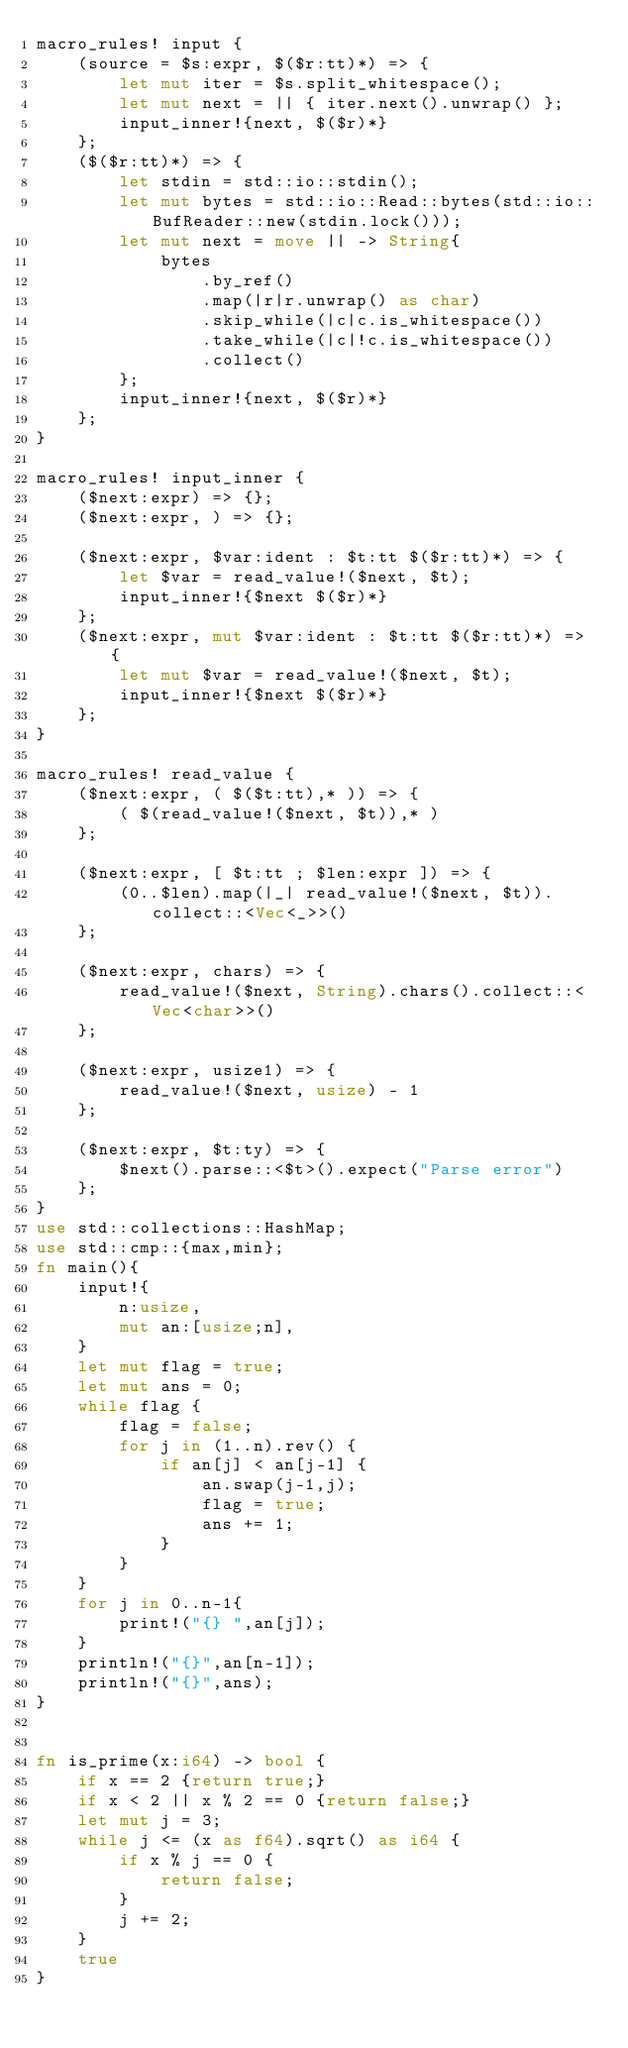<code> <loc_0><loc_0><loc_500><loc_500><_Rust_>macro_rules! input {
    (source = $s:expr, $($r:tt)*) => {
        let mut iter = $s.split_whitespace();
        let mut next = || { iter.next().unwrap() };
        input_inner!{next, $($r)*}
    };
    ($($r:tt)*) => {
        let stdin = std::io::stdin();
        let mut bytes = std::io::Read::bytes(std::io::BufReader::new(stdin.lock()));
        let mut next = move || -> String{
            bytes
                .by_ref()
                .map(|r|r.unwrap() as char)
                .skip_while(|c|c.is_whitespace())
                .take_while(|c|!c.is_whitespace())
                .collect()
        };
        input_inner!{next, $($r)*}
    };
}

macro_rules! input_inner {
    ($next:expr) => {};
    ($next:expr, ) => {};

    ($next:expr, $var:ident : $t:tt $($r:tt)*) => {
        let $var = read_value!($next, $t);
        input_inner!{$next $($r)*}
    };
    ($next:expr, mut $var:ident : $t:tt $($r:tt)*) => {
        let mut $var = read_value!($next, $t);
        input_inner!{$next $($r)*}
    };
}

macro_rules! read_value {
    ($next:expr, ( $($t:tt),* )) => {
        ( $(read_value!($next, $t)),* )
    };

    ($next:expr, [ $t:tt ; $len:expr ]) => {
        (0..$len).map(|_| read_value!($next, $t)).collect::<Vec<_>>()
    };

    ($next:expr, chars) => {
        read_value!($next, String).chars().collect::<Vec<char>>()
    };

    ($next:expr, usize1) => {
        read_value!($next, usize) - 1
    };

    ($next:expr, $t:ty) => {
        $next().parse::<$t>().expect("Parse error")
    };
}
use std::collections::HashMap;
use std::cmp::{max,min};
fn main(){
    input!{
        n:usize,
        mut an:[usize;n],
    }
    let mut flag = true;
    let mut ans = 0;
    while flag {
        flag = false;
        for j in (1..n).rev() {
            if an[j] < an[j-1] {
                an.swap(j-1,j);
                flag = true;
                ans += 1;
            }
        }
    }
    for j in 0..n-1{
        print!("{} ",an[j]);
    }
    println!("{}",an[n-1]);
    println!("{}",ans);
}


fn is_prime(x:i64) -> bool {
    if x == 2 {return true;}
    if x < 2 || x % 2 == 0 {return false;}
    let mut j = 3;
    while j <= (x as f64).sqrt() as i64 {
        if x % j == 0 {
            return false;
        }
        j += 2;
    }
    true
}

</code> 